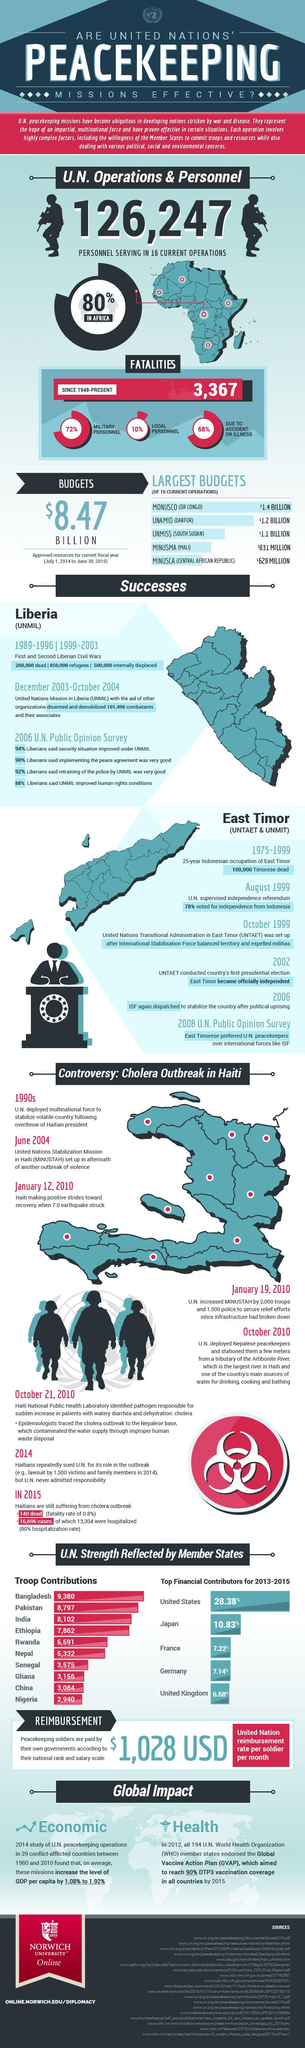Indicate a few pertinent items in this graphic. The United Nations operates the second largest budget in a region known as Darfur. The United Nations Peace Missions, UNTAET and UNMIT, played a crucial role in the independence of East Timor. In early 2010, a catastrophic 7.0 earthquake struck the impoverished Caribbean nation of Haiti, causing widespread devastation and loss of life. The disaster left hundreds of thousands of Haitians homeless and exposed the country's fragile infrastructure and poverty-stricken conditions. The earthquake also drew global attention to Haiti's humanitarian crisis and prompted a massive international relief effort. Haiti relies heavily on the Artibonite River as its primary source of water. In October 2010, Haiti was struck by an epidemic of cholera. 